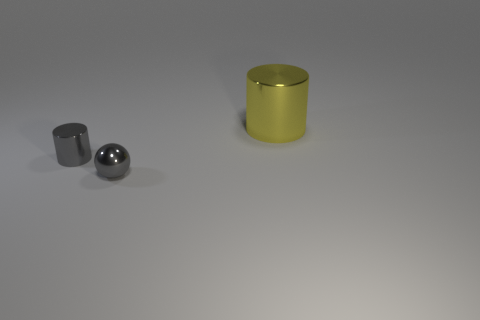Is there any other thing that has the same size as the yellow object?
Your response must be concise. No. What number of other objects are there of the same material as the sphere?
Your answer should be very brief. 2. Is there a tiny red object that has the same shape as the big thing?
Provide a short and direct response. No. What number of objects are either metal cylinders left of the small sphere or gray things?
Provide a short and direct response. 2. Is the number of cyan shiny balls greater than the number of small gray things?
Ensure brevity in your answer.  No. Is there a cyan matte object that has the same size as the gray metal ball?
Your answer should be very brief. No. What number of objects are small gray objects that are left of the gray ball or metallic cylinders that are left of the yellow cylinder?
Make the answer very short. 1. There is a small thing that is in front of the gray object behind the sphere; what color is it?
Provide a succinct answer. Gray. What is the color of the tiny ball that is made of the same material as the yellow object?
Provide a short and direct response. Gray. How many metallic spheres have the same color as the tiny shiny cylinder?
Provide a succinct answer. 1. 